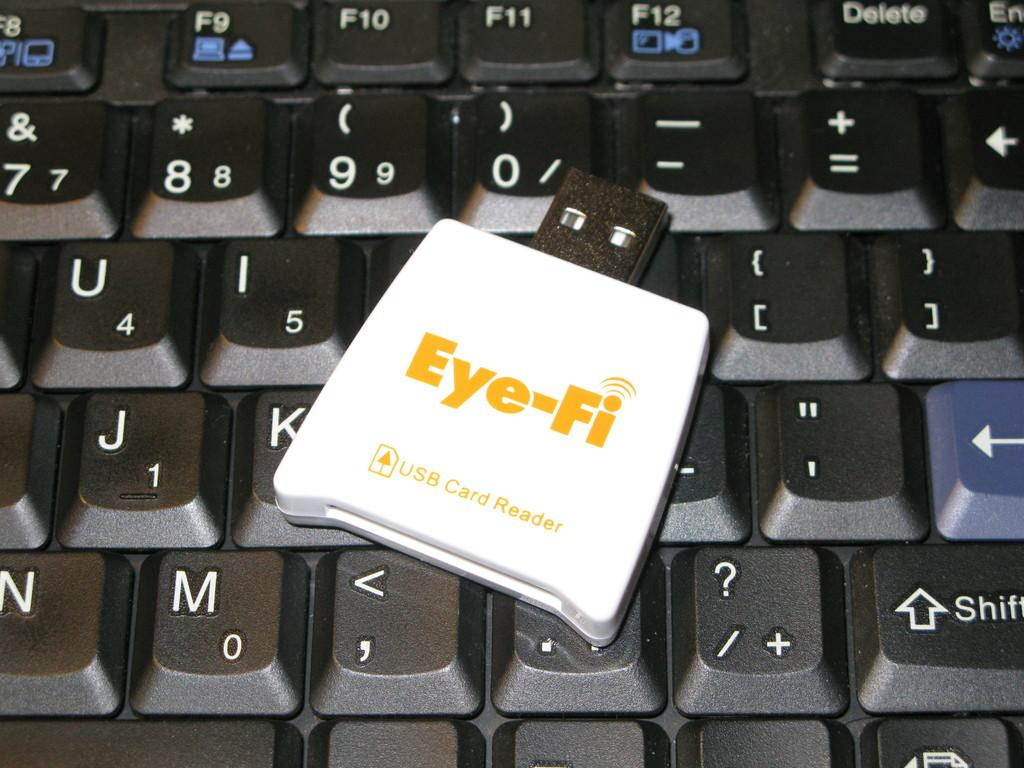What is the main object in the image? There is a keyboard in the image. How is the keyboard depicted in the image? The keyboard is truncated in the image. What additional feature can be seen on the keyboard? There is a card reader on the keyboard. Where is the basket located in the image? There is no basket present in the image. What does the keyboard look like in the image? The keyboard is truncated in the image, so it appears incomplete. 